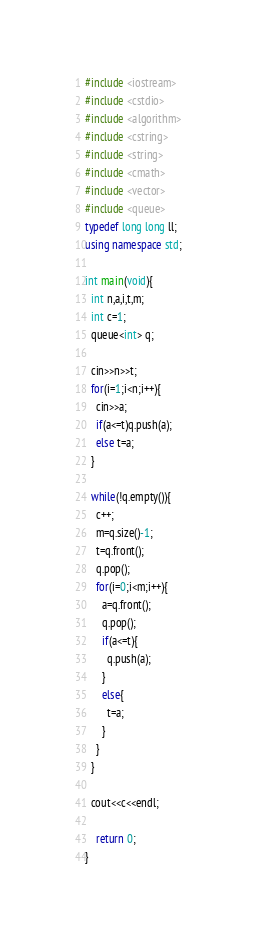<code> <loc_0><loc_0><loc_500><loc_500><_C++_>#include <iostream>
#include <cstdio>
#include <algorithm>
#include <cstring>
#include <string>
#include <cmath>
#include <vector>
#include <queue>
typedef long long ll;
using namespace std;

int main(void){
  int n,a,i,t,m;
  int c=1;
  queue<int> q;

  cin>>n>>t;
  for(i=1;i<n;i++){
    cin>>a;
    if(a<=t)q.push(a);
    else t=a;
  }

  while(!q.empty()){
    c++;
    m=q.size()-1;
    t=q.front();
    q.pop();
    for(i=0;i<m;i++){
      a=q.front();
      q.pop();
      if(a<=t){
        q.push(a);
      }
      else{
        t=a;
      }
    }
  }

  cout<<c<<endl;

	return 0;
}</code> 